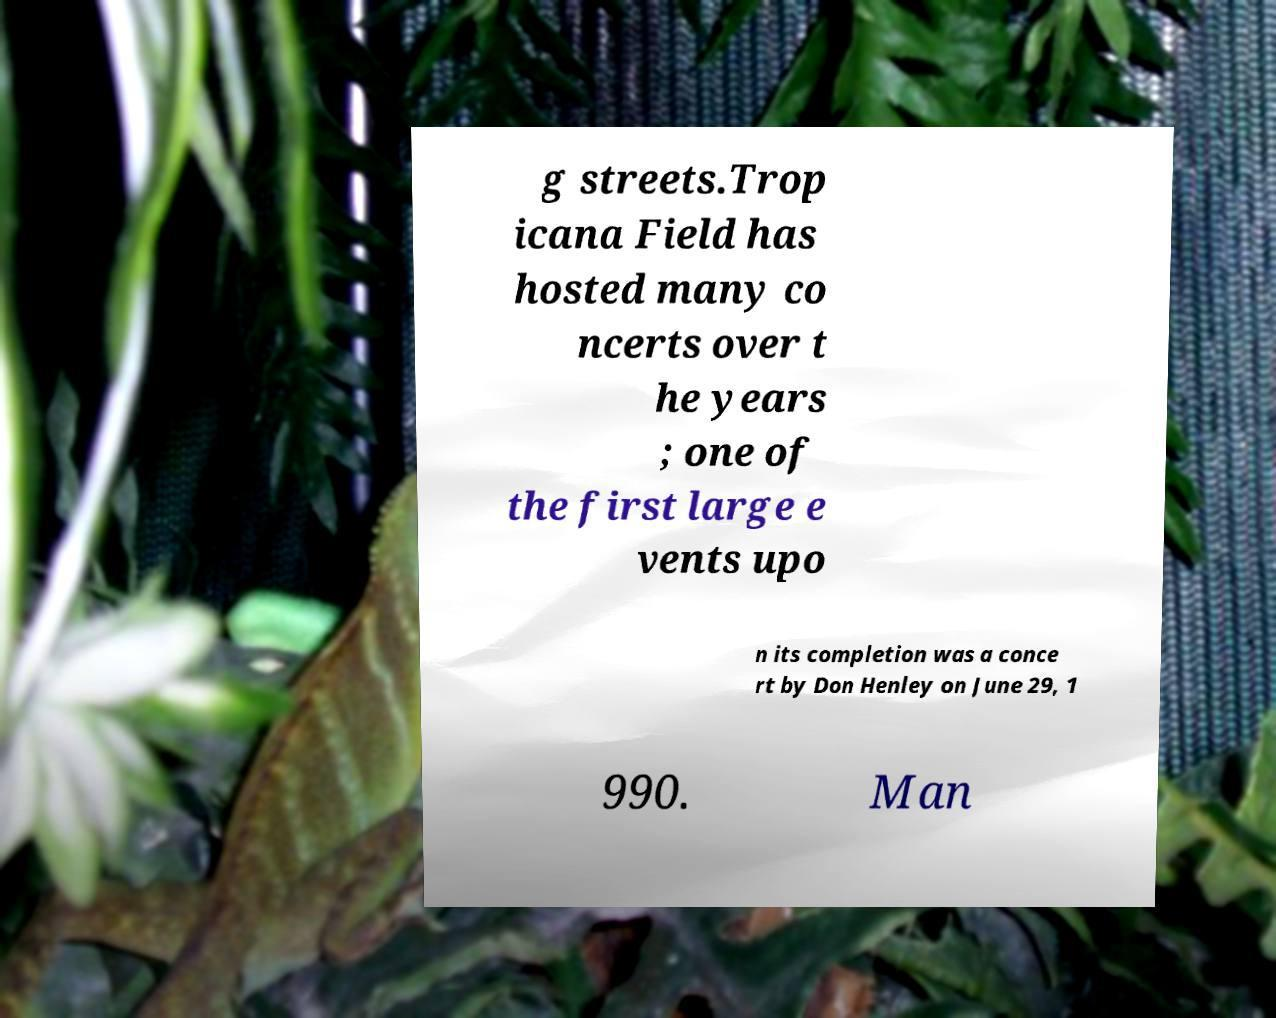What messages or text are displayed in this image? I need them in a readable, typed format. g streets.Trop icana Field has hosted many co ncerts over t he years ; one of the first large e vents upo n its completion was a conce rt by Don Henley on June 29, 1 990. Man 